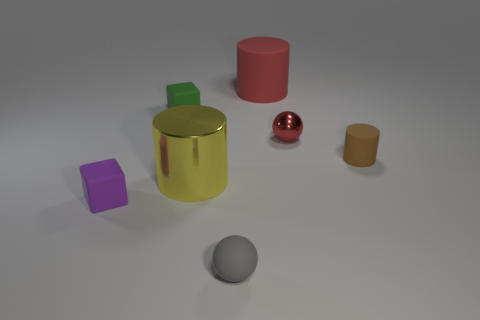Add 3 tiny blue matte objects. How many objects exist? 10 Subtract all cylinders. How many objects are left? 4 Add 5 gray rubber objects. How many gray rubber objects exist? 6 Subtract 1 red spheres. How many objects are left? 6 Subtract all big brown cylinders. Subtract all tiny gray things. How many objects are left? 6 Add 1 green blocks. How many green blocks are left? 2 